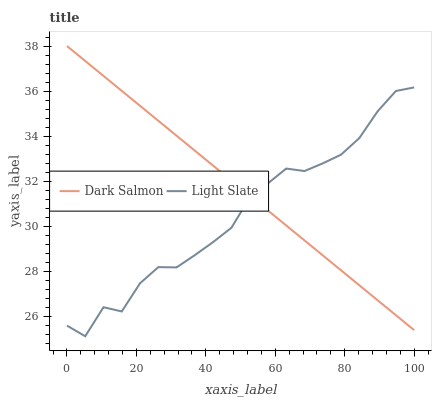Does Light Slate have the minimum area under the curve?
Answer yes or no. Yes. Does Dark Salmon have the maximum area under the curve?
Answer yes or no. Yes. Does Dark Salmon have the minimum area under the curve?
Answer yes or no. No. Is Dark Salmon the smoothest?
Answer yes or no. Yes. Is Light Slate the roughest?
Answer yes or no. Yes. Is Dark Salmon the roughest?
Answer yes or no. No. Does Light Slate have the lowest value?
Answer yes or no. Yes. Does Dark Salmon have the lowest value?
Answer yes or no. No. Does Dark Salmon have the highest value?
Answer yes or no. Yes. Does Light Slate intersect Dark Salmon?
Answer yes or no. Yes. Is Light Slate less than Dark Salmon?
Answer yes or no. No. Is Light Slate greater than Dark Salmon?
Answer yes or no. No. 